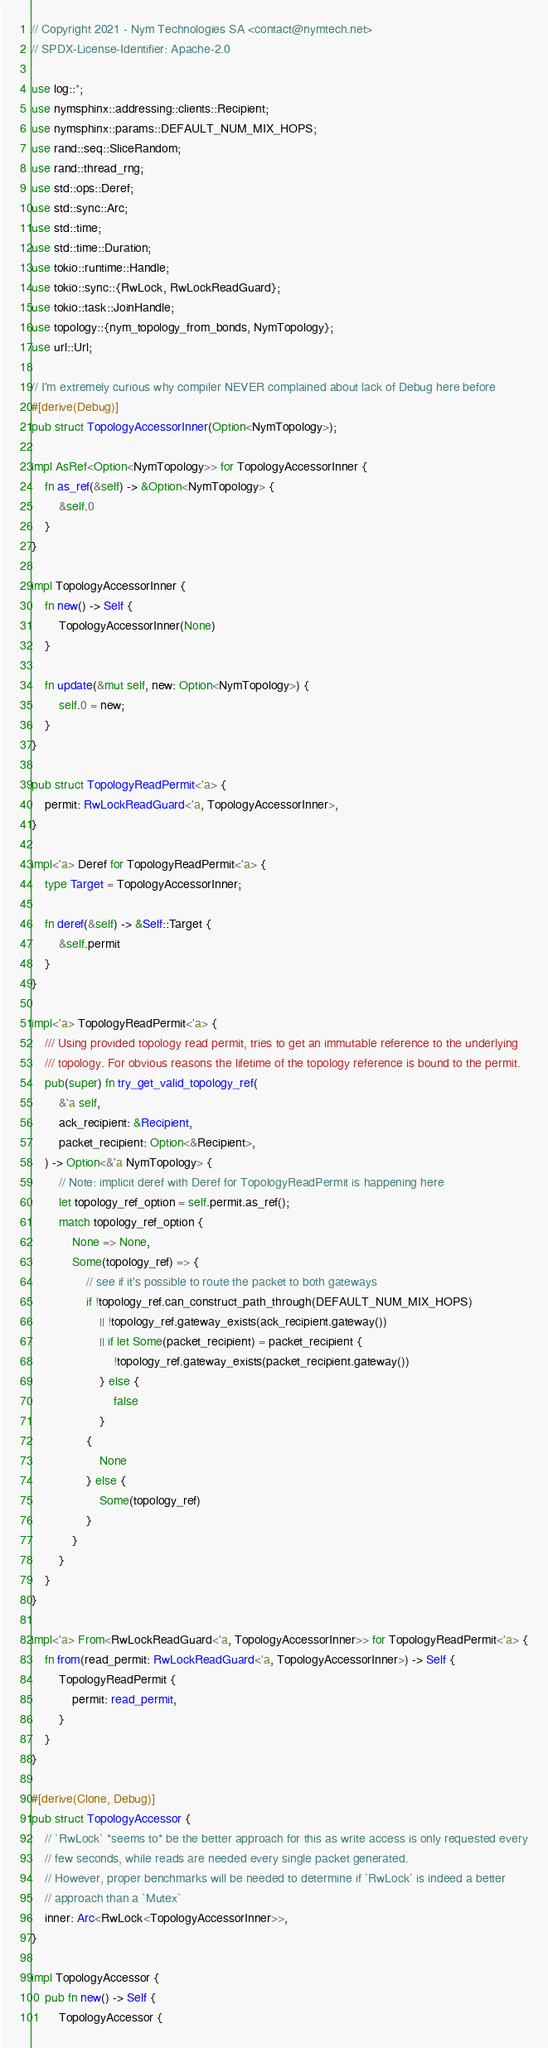<code> <loc_0><loc_0><loc_500><loc_500><_Rust_>// Copyright 2021 - Nym Technologies SA <contact@nymtech.net>
// SPDX-License-Identifier: Apache-2.0

use log::*;
use nymsphinx::addressing::clients::Recipient;
use nymsphinx::params::DEFAULT_NUM_MIX_HOPS;
use rand::seq::SliceRandom;
use rand::thread_rng;
use std::ops::Deref;
use std::sync::Arc;
use std::time;
use std::time::Duration;
use tokio::runtime::Handle;
use tokio::sync::{RwLock, RwLockReadGuard};
use tokio::task::JoinHandle;
use topology::{nym_topology_from_bonds, NymTopology};
use url::Url;

// I'm extremely curious why compiler NEVER complained about lack of Debug here before
#[derive(Debug)]
pub struct TopologyAccessorInner(Option<NymTopology>);

impl AsRef<Option<NymTopology>> for TopologyAccessorInner {
    fn as_ref(&self) -> &Option<NymTopology> {
        &self.0
    }
}

impl TopologyAccessorInner {
    fn new() -> Self {
        TopologyAccessorInner(None)
    }

    fn update(&mut self, new: Option<NymTopology>) {
        self.0 = new;
    }
}

pub struct TopologyReadPermit<'a> {
    permit: RwLockReadGuard<'a, TopologyAccessorInner>,
}

impl<'a> Deref for TopologyReadPermit<'a> {
    type Target = TopologyAccessorInner;

    fn deref(&self) -> &Self::Target {
        &self.permit
    }
}

impl<'a> TopologyReadPermit<'a> {
    /// Using provided topology read permit, tries to get an immutable reference to the underlying
    /// topology. For obvious reasons the lifetime of the topology reference is bound to the permit.
    pub(super) fn try_get_valid_topology_ref(
        &'a self,
        ack_recipient: &Recipient,
        packet_recipient: Option<&Recipient>,
    ) -> Option<&'a NymTopology> {
        // Note: implicit deref with Deref for TopologyReadPermit is happening here
        let topology_ref_option = self.permit.as_ref();
        match topology_ref_option {
            None => None,
            Some(topology_ref) => {
                // see if it's possible to route the packet to both gateways
                if !topology_ref.can_construct_path_through(DEFAULT_NUM_MIX_HOPS)
                    || !topology_ref.gateway_exists(ack_recipient.gateway())
                    || if let Some(packet_recipient) = packet_recipient {
                        !topology_ref.gateway_exists(packet_recipient.gateway())
                    } else {
                        false
                    }
                {
                    None
                } else {
                    Some(topology_ref)
                }
            }
        }
    }
}

impl<'a> From<RwLockReadGuard<'a, TopologyAccessorInner>> for TopologyReadPermit<'a> {
    fn from(read_permit: RwLockReadGuard<'a, TopologyAccessorInner>) -> Self {
        TopologyReadPermit {
            permit: read_permit,
        }
    }
}

#[derive(Clone, Debug)]
pub struct TopologyAccessor {
    // `RwLock` *seems to* be the better approach for this as write access is only requested every
    // few seconds, while reads are needed every single packet generated.
    // However, proper benchmarks will be needed to determine if `RwLock` is indeed a better
    // approach than a `Mutex`
    inner: Arc<RwLock<TopologyAccessorInner>>,
}

impl TopologyAccessor {
    pub fn new() -> Self {
        TopologyAccessor {</code> 